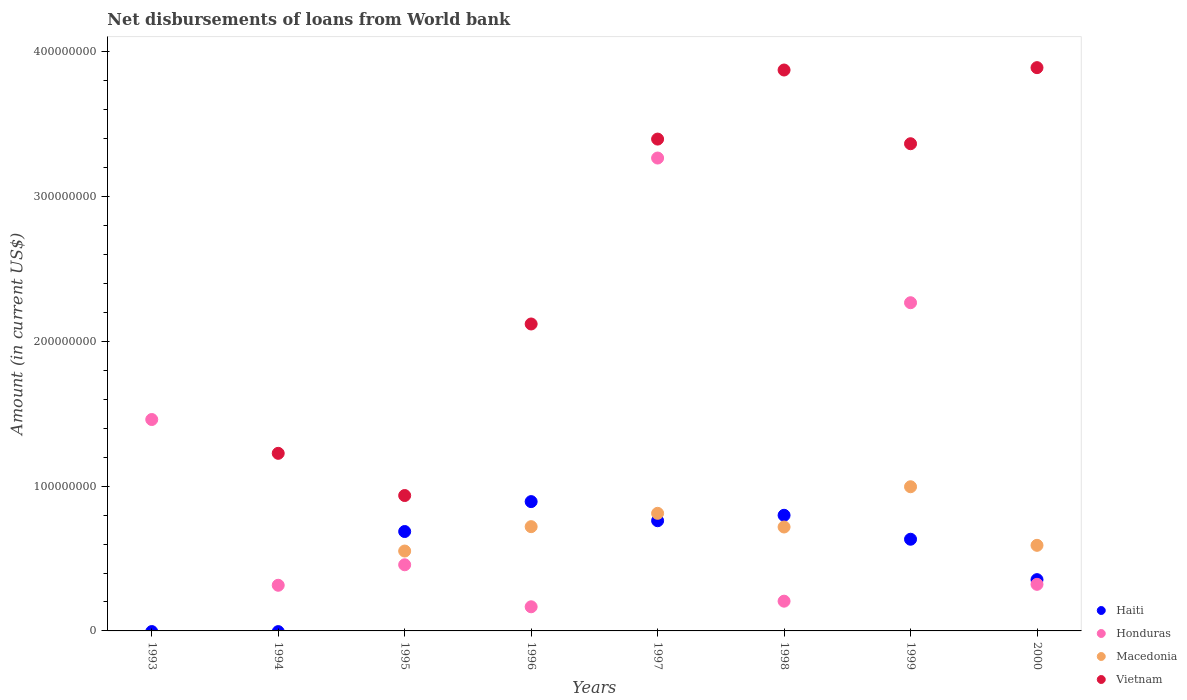Is the number of dotlines equal to the number of legend labels?
Your response must be concise. No. What is the amount of loan disbursed from World Bank in Haiti in 1999?
Offer a very short reply. 6.33e+07. Across all years, what is the maximum amount of loan disbursed from World Bank in Macedonia?
Offer a very short reply. 9.96e+07. What is the total amount of loan disbursed from World Bank in Vietnam in the graph?
Provide a succinct answer. 1.88e+09. What is the difference between the amount of loan disbursed from World Bank in Honduras in 1994 and that in 1998?
Give a very brief answer. 1.10e+07. What is the difference between the amount of loan disbursed from World Bank in Honduras in 1994 and the amount of loan disbursed from World Bank in Macedonia in 1997?
Provide a succinct answer. -4.97e+07. What is the average amount of loan disbursed from World Bank in Vietnam per year?
Ensure brevity in your answer.  2.35e+08. In the year 2000, what is the difference between the amount of loan disbursed from World Bank in Vietnam and amount of loan disbursed from World Bank in Macedonia?
Give a very brief answer. 3.30e+08. In how many years, is the amount of loan disbursed from World Bank in Haiti greater than 340000000 US$?
Ensure brevity in your answer.  0. What is the ratio of the amount of loan disbursed from World Bank in Honduras in 1995 to that in 1998?
Give a very brief answer. 2.22. Is the difference between the amount of loan disbursed from World Bank in Vietnam in 1995 and 1998 greater than the difference between the amount of loan disbursed from World Bank in Macedonia in 1995 and 1998?
Make the answer very short. No. What is the difference between the highest and the second highest amount of loan disbursed from World Bank in Haiti?
Provide a short and direct response. 9.45e+06. What is the difference between the highest and the lowest amount of loan disbursed from World Bank in Macedonia?
Make the answer very short. 9.96e+07. Does the amount of loan disbursed from World Bank in Vietnam monotonically increase over the years?
Make the answer very short. No. Is the amount of loan disbursed from World Bank in Haiti strictly greater than the amount of loan disbursed from World Bank in Honduras over the years?
Your answer should be very brief. No. How many dotlines are there?
Make the answer very short. 4. Are the values on the major ticks of Y-axis written in scientific E-notation?
Provide a short and direct response. No. Does the graph contain any zero values?
Your answer should be compact. Yes. Does the graph contain grids?
Make the answer very short. No. What is the title of the graph?
Provide a succinct answer. Net disbursements of loans from World bank. What is the label or title of the X-axis?
Provide a succinct answer. Years. What is the label or title of the Y-axis?
Provide a short and direct response. Amount (in current US$). What is the Amount (in current US$) of Haiti in 1993?
Keep it short and to the point. 0. What is the Amount (in current US$) of Honduras in 1993?
Make the answer very short. 1.46e+08. What is the Amount (in current US$) in Macedonia in 1993?
Ensure brevity in your answer.  0. What is the Amount (in current US$) in Vietnam in 1993?
Your answer should be very brief. 0. What is the Amount (in current US$) in Honduras in 1994?
Your answer should be compact. 3.15e+07. What is the Amount (in current US$) of Vietnam in 1994?
Your answer should be very brief. 1.23e+08. What is the Amount (in current US$) of Haiti in 1995?
Offer a very short reply. 6.87e+07. What is the Amount (in current US$) of Honduras in 1995?
Your answer should be compact. 4.57e+07. What is the Amount (in current US$) of Macedonia in 1995?
Offer a terse response. 5.52e+07. What is the Amount (in current US$) in Vietnam in 1995?
Your answer should be very brief. 9.35e+07. What is the Amount (in current US$) of Haiti in 1996?
Offer a very short reply. 8.93e+07. What is the Amount (in current US$) of Honduras in 1996?
Provide a succinct answer. 1.67e+07. What is the Amount (in current US$) of Macedonia in 1996?
Keep it short and to the point. 7.20e+07. What is the Amount (in current US$) in Vietnam in 1996?
Keep it short and to the point. 2.12e+08. What is the Amount (in current US$) in Haiti in 1997?
Give a very brief answer. 7.61e+07. What is the Amount (in current US$) in Honduras in 1997?
Offer a terse response. 3.27e+08. What is the Amount (in current US$) in Macedonia in 1997?
Your response must be concise. 8.12e+07. What is the Amount (in current US$) in Vietnam in 1997?
Provide a short and direct response. 3.40e+08. What is the Amount (in current US$) of Haiti in 1998?
Ensure brevity in your answer.  7.99e+07. What is the Amount (in current US$) in Honduras in 1998?
Your response must be concise. 2.05e+07. What is the Amount (in current US$) of Macedonia in 1998?
Offer a very short reply. 7.18e+07. What is the Amount (in current US$) of Vietnam in 1998?
Keep it short and to the point. 3.87e+08. What is the Amount (in current US$) in Haiti in 1999?
Provide a succinct answer. 6.33e+07. What is the Amount (in current US$) of Honduras in 1999?
Offer a very short reply. 2.27e+08. What is the Amount (in current US$) of Macedonia in 1999?
Your response must be concise. 9.96e+07. What is the Amount (in current US$) in Vietnam in 1999?
Offer a terse response. 3.36e+08. What is the Amount (in current US$) in Haiti in 2000?
Your response must be concise. 3.54e+07. What is the Amount (in current US$) of Honduras in 2000?
Your response must be concise. 3.22e+07. What is the Amount (in current US$) in Macedonia in 2000?
Offer a terse response. 5.91e+07. What is the Amount (in current US$) of Vietnam in 2000?
Your answer should be compact. 3.89e+08. Across all years, what is the maximum Amount (in current US$) of Haiti?
Provide a short and direct response. 8.93e+07. Across all years, what is the maximum Amount (in current US$) in Honduras?
Give a very brief answer. 3.27e+08. Across all years, what is the maximum Amount (in current US$) in Macedonia?
Offer a terse response. 9.96e+07. Across all years, what is the maximum Amount (in current US$) in Vietnam?
Your answer should be very brief. 3.89e+08. Across all years, what is the minimum Amount (in current US$) in Haiti?
Make the answer very short. 0. Across all years, what is the minimum Amount (in current US$) of Honduras?
Offer a very short reply. 1.67e+07. What is the total Amount (in current US$) in Haiti in the graph?
Your answer should be compact. 4.13e+08. What is the total Amount (in current US$) of Honduras in the graph?
Provide a succinct answer. 8.46e+08. What is the total Amount (in current US$) of Macedonia in the graph?
Keep it short and to the point. 4.39e+08. What is the total Amount (in current US$) in Vietnam in the graph?
Offer a terse response. 1.88e+09. What is the difference between the Amount (in current US$) of Honduras in 1993 and that in 1994?
Offer a very short reply. 1.14e+08. What is the difference between the Amount (in current US$) in Honduras in 1993 and that in 1995?
Your answer should be compact. 1.00e+08. What is the difference between the Amount (in current US$) of Honduras in 1993 and that in 1996?
Your response must be concise. 1.29e+08. What is the difference between the Amount (in current US$) of Honduras in 1993 and that in 1997?
Give a very brief answer. -1.81e+08. What is the difference between the Amount (in current US$) of Honduras in 1993 and that in 1998?
Provide a short and direct response. 1.25e+08. What is the difference between the Amount (in current US$) in Honduras in 1993 and that in 1999?
Make the answer very short. -8.07e+07. What is the difference between the Amount (in current US$) in Honduras in 1993 and that in 2000?
Keep it short and to the point. 1.14e+08. What is the difference between the Amount (in current US$) in Honduras in 1994 and that in 1995?
Ensure brevity in your answer.  -1.41e+07. What is the difference between the Amount (in current US$) of Vietnam in 1994 and that in 1995?
Your answer should be very brief. 2.91e+07. What is the difference between the Amount (in current US$) in Honduras in 1994 and that in 1996?
Your answer should be compact. 1.49e+07. What is the difference between the Amount (in current US$) in Vietnam in 1994 and that in 1996?
Make the answer very short. -8.93e+07. What is the difference between the Amount (in current US$) of Honduras in 1994 and that in 1997?
Provide a short and direct response. -2.95e+08. What is the difference between the Amount (in current US$) of Vietnam in 1994 and that in 1997?
Provide a short and direct response. -2.17e+08. What is the difference between the Amount (in current US$) in Honduras in 1994 and that in 1998?
Your answer should be compact. 1.10e+07. What is the difference between the Amount (in current US$) of Vietnam in 1994 and that in 1998?
Keep it short and to the point. -2.65e+08. What is the difference between the Amount (in current US$) of Honduras in 1994 and that in 1999?
Provide a succinct answer. -1.95e+08. What is the difference between the Amount (in current US$) of Vietnam in 1994 and that in 1999?
Ensure brevity in your answer.  -2.14e+08. What is the difference between the Amount (in current US$) of Honduras in 1994 and that in 2000?
Offer a very short reply. -6.47e+05. What is the difference between the Amount (in current US$) of Vietnam in 1994 and that in 2000?
Your answer should be very brief. -2.66e+08. What is the difference between the Amount (in current US$) of Haiti in 1995 and that in 1996?
Keep it short and to the point. -2.07e+07. What is the difference between the Amount (in current US$) of Honduras in 1995 and that in 1996?
Your answer should be very brief. 2.90e+07. What is the difference between the Amount (in current US$) in Macedonia in 1995 and that in 1996?
Provide a short and direct response. -1.68e+07. What is the difference between the Amount (in current US$) of Vietnam in 1995 and that in 1996?
Your response must be concise. -1.18e+08. What is the difference between the Amount (in current US$) of Haiti in 1995 and that in 1997?
Your response must be concise. -7.46e+06. What is the difference between the Amount (in current US$) in Honduras in 1995 and that in 1997?
Your response must be concise. -2.81e+08. What is the difference between the Amount (in current US$) in Macedonia in 1995 and that in 1997?
Keep it short and to the point. -2.60e+07. What is the difference between the Amount (in current US$) of Vietnam in 1995 and that in 1997?
Offer a terse response. -2.46e+08. What is the difference between the Amount (in current US$) in Haiti in 1995 and that in 1998?
Keep it short and to the point. -1.12e+07. What is the difference between the Amount (in current US$) of Honduras in 1995 and that in 1998?
Offer a very short reply. 2.51e+07. What is the difference between the Amount (in current US$) in Macedonia in 1995 and that in 1998?
Your response must be concise. -1.66e+07. What is the difference between the Amount (in current US$) in Vietnam in 1995 and that in 1998?
Provide a succinct answer. -2.94e+08. What is the difference between the Amount (in current US$) of Haiti in 1995 and that in 1999?
Ensure brevity in your answer.  5.33e+06. What is the difference between the Amount (in current US$) of Honduras in 1995 and that in 1999?
Offer a terse response. -1.81e+08. What is the difference between the Amount (in current US$) of Macedonia in 1995 and that in 1999?
Offer a very short reply. -4.44e+07. What is the difference between the Amount (in current US$) in Vietnam in 1995 and that in 1999?
Provide a short and direct response. -2.43e+08. What is the difference between the Amount (in current US$) of Haiti in 1995 and that in 2000?
Offer a very short reply. 3.32e+07. What is the difference between the Amount (in current US$) in Honduras in 1995 and that in 2000?
Ensure brevity in your answer.  1.35e+07. What is the difference between the Amount (in current US$) of Macedonia in 1995 and that in 2000?
Keep it short and to the point. -3.94e+06. What is the difference between the Amount (in current US$) of Vietnam in 1995 and that in 2000?
Offer a very short reply. -2.96e+08. What is the difference between the Amount (in current US$) of Haiti in 1996 and that in 1997?
Offer a terse response. 1.32e+07. What is the difference between the Amount (in current US$) of Honduras in 1996 and that in 1997?
Ensure brevity in your answer.  -3.10e+08. What is the difference between the Amount (in current US$) of Macedonia in 1996 and that in 1997?
Your response must be concise. -9.21e+06. What is the difference between the Amount (in current US$) in Vietnam in 1996 and that in 1997?
Give a very brief answer. -1.28e+08. What is the difference between the Amount (in current US$) in Haiti in 1996 and that in 1998?
Make the answer very short. 9.45e+06. What is the difference between the Amount (in current US$) in Honduras in 1996 and that in 1998?
Offer a very short reply. -3.87e+06. What is the difference between the Amount (in current US$) of Macedonia in 1996 and that in 1998?
Ensure brevity in your answer.  2.31e+05. What is the difference between the Amount (in current US$) in Vietnam in 1996 and that in 1998?
Your answer should be compact. -1.75e+08. What is the difference between the Amount (in current US$) in Haiti in 1996 and that in 1999?
Make the answer very short. 2.60e+07. What is the difference between the Amount (in current US$) in Honduras in 1996 and that in 1999?
Make the answer very short. -2.10e+08. What is the difference between the Amount (in current US$) of Macedonia in 1996 and that in 1999?
Offer a terse response. -2.76e+07. What is the difference between the Amount (in current US$) of Vietnam in 1996 and that in 1999?
Make the answer very short. -1.24e+08. What is the difference between the Amount (in current US$) in Haiti in 1996 and that in 2000?
Ensure brevity in your answer.  5.39e+07. What is the difference between the Amount (in current US$) in Honduras in 1996 and that in 2000?
Offer a very short reply. -1.55e+07. What is the difference between the Amount (in current US$) in Macedonia in 1996 and that in 2000?
Give a very brief answer. 1.29e+07. What is the difference between the Amount (in current US$) of Vietnam in 1996 and that in 2000?
Ensure brevity in your answer.  -1.77e+08. What is the difference between the Amount (in current US$) in Haiti in 1997 and that in 1998?
Offer a very short reply. -3.75e+06. What is the difference between the Amount (in current US$) of Honduras in 1997 and that in 1998?
Provide a short and direct response. 3.06e+08. What is the difference between the Amount (in current US$) in Macedonia in 1997 and that in 1998?
Give a very brief answer. 9.44e+06. What is the difference between the Amount (in current US$) of Vietnam in 1997 and that in 1998?
Give a very brief answer. -4.77e+07. What is the difference between the Amount (in current US$) of Haiti in 1997 and that in 1999?
Your answer should be compact. 1.28e+07. What is the difference between the Amount (in current US$) of Honduras in 1997 and that in 1999?
Offer a terse response. 9.99e+07. What is the difference between the Amount (in current US$) of Macedonia in 1997 and that in 1999?
Offer a terse response. -1.84e+07. What is the difference between the Amount (in current US$) in Vietnam in 1997 and that in 1999?
Offer a terse response. 3.21e+06. What is the difference between the Amount (in current US$) in Haiti in 1997 and that in 2000?
Provide a short and direct response. 4.07e+07. What is the difference between the Amount (in current US$) of Honduras in 1997 and that in 2000?
Give a very brief answer. 2.94e+08. What is the difference between the Amount (in current US$) in Macedonia in 1997 and that in 2000?
Your answer should be very brief. 2.21e+07. What is the difference between the Amount (in current US$) of Vietnam in 1997 and that in 2000?
Ensure brevity in your answer.  -4.93e+07. What is the difference between the Amount (in current US$) in Haiti in 1998 and that in 1999?
Your answer should be compact. 1.65e+07. What is the difference between the Amount (in current US$) in Honduras in 1998 and that in 1999?
Keep it short and to the point. -2.06e+08. What is the difference between the Amount (in current US$) of Macedonia in 1998 and that in 1999?
Your response must be concise. -2.78e+07. What is the difference between the Amount (in current US$) in Vietnam in 1998 and that in 1999?
Your answer should be compact. 5.09e+07. What is the difference between the Amount (in current US$) of Haiti in 1998 and that in 2000?
Make the answer very short. 4.44e+07. What is the difference between the Amount (in current US$) of Honduras in 1998 and that in 2000?
Give a very brief answer. -1.16e+07. What is the difference between the Amount (in current US$) of Macedonia in 1998 and that in 2000?
Give a very brief answer. 1.27e+07. What is the difference between the Amount (in current US$) in Vietnam in 1998 and that in 2000?
Keep it short and to the point. -1.64e+06. What is the difference between the Amount (in current US$) in Haiti in 1999 and that in 2000?
Your answer should be very brief. 2.79e+07. What is the difference between the Amount (in current US$) in Honduras in 1999 and that in 2000?
Provide a short and direct response. 1.94e+08. What is the difference between the Amount (in current US$) of Macedonia in 1999 and that in 2000?
Offer a very short reply. 4.05e+07. What is the difference between the Amount (in current US$) in Vietnam in 1999 and that in 2000?
Ensure brevity in your answer.  -5.26e+07. What is the difference between the Amount (in current US$) of Honduras in 1993 and the Amount (in current US$) of Vietnam in 1994?
Make the answer very short. 2.34e+07. What is the difference between the Amount (in current US$) of Honduras in 1993 and the Amount (in current US$) of Macedonia in 1995?
Make the answer very short. 9.08e+07. What is the difference between the Amount (in current US$) in Honduras in 1993 and the Amount (in current US$) in Vietnam in 1995?
Provide a succinct answer. 5.25e+07. What is the difference between the Amount (in current US$) of Honduras in 1993 and the Amount (in current US$) of Macedonia in 1996?
Keep it short and to the point. 7.40e+07. What is the difference between the Amount (in current US$) of Honduras in 1993 and the Amount (in current US$) of Vietnam in 1996?
Give a very brief answer. -6.60e+07. What is the difference between the Amount (in current US$) of Honduras in 1993 and the Amount (in current US$) of Macedonia in 1997?
Provide a succinct answer. 6.48e+07. What is the difference between the Amount (in current US$) in Honduras in 1993 and the Amount (in current US$) in Vietnam in 1997?
Offer a terse response. -1.94e+08. What is the difference between the Amount (in current US$) in Honduras in 1993 and the Amount (in current US$) in Macedonia in 1998?
Keep it short and to the point. 7.42e+07. What is the difference between the Amount (in current US$) of Honduras in 1993 and the Amount (in current US$) of Vietnam in 1998?
Offer a very short reply. -2.41e+08. What is the difference between the Amount (in current US$) in Honduras in 1993 and the Amount (in current US$) in Macedonia in 1999?
Make the answer very short. 4.64e+07. What is the difference between the Amount (in current US$) in Honduras in 1993 and the Amount (in current US$) in Vietnam in 1999?
Your response must be concise. -1.90e+08. What is the difference between the Amount (in current US$) of Honduras in 1993 and the Amount (in current US$) of Macedonia in 2000?
Offer a very short reply. 8.69e+07. What is the difference between the Amount (in current US$) in Honduras in 1993 and the Amount (in current US$) in Vietnam in 2000?
Provide a short and direct response. -2.43e+08. What is the difference between the Amount (in current US$) in Honduras in 1994 and the Amount (in current US$) in Macedonia in 1995?
Offer a terse response. -2.36e+07. What is the difference between the Amount (in current US$) of Honduras in 1994 and the Amount (in current US$) of Vietnam in 1995?
Ensure brevity in your answer.  -6.20e+07. What is the difference between the Amount (in current US$) of Honduras in 1994 and the Amount (in current US$) of Macedonia in 1996?
Make the answer very short. -4.05e+07. What is the difference between the Amount (in current US$) of Honduras in 1994 and the Amount (in current US$) of Vietnam in 1996?
Provide a succinct answer. -1.80e+08. What is the difference between the Amount (in current US$) in Honduras in 1994 and the Amount (in current US$) in Macedonia in 1997?
Keep it short and to the point. -4.97e+07. What is the difference between the Amount (in current US$) of Honduras in 1994 and the Amount (in current US$) of Vietnam in 1997?
Ensure brevity in your answer.  -3.08e+08. What is the difference between the Amount (in current US$) of Honduras in 1994 and the Amount (in current US$) of Macedonia in 1998?
Your response must be concise. -4.02e+07. What is the difference between the Amount (in current US$) in Honduras in 1994 and the Amount (in current US$) in Vietnam in 1998?
Give a very brief answer. -3.56e+08. What is the difference between the Amount (in current US$) of Honduras in 1994 and the Amount (in current US$) of Macedonia in 1999?
Give a very brief answer. -6.80e+07. What is the difference between the Amount (in current US$) of Honduras in 1994 and the Amount (in current US$) of Vietnam in 1999?
Your answer should be compact. -3.05e+08. What is the difference between the Amount (in current US$) in Honduras in 1994 and the Amount (in current US$) in Macedonia in 2000?
Offer a very short reply. -2.76e+07. What is the difference between the Amount (in current US$) in Honduras in 1994 and the Amount (in current US$) in Vietnam in 2000?
Ensure brevity in your answer.  -3.58e+08. What is the difference between the Amount (in current US$) in Haiti in 1995 and the Amount (in current US$) in Honduras in 1996?
Your answer should be very brief. 5.20e+07. What is the difference between the Amount (in current US$) of Haiti in 1995 and the Amount (in current US$) of Macedonia in 1996?
Ensure brevity in your answer.  -3.36e+06. What is the difference between the Amount (in current US$) in Haiti in 1995 and the Amount (in current US$) in Vietnam in 1996?
Provide a short and direct response. -1.43e+08. What is the difference between the Amount (in current US$) in Honduras in 1995 and the Amount (in current US$) in Macedonia in 1996?
Ensure brevity in your answer.  -2.63e+07. What is the difference between the Amount (in current US$) in Honduras in 1995 and the Amount (in current US$) in Vietnam in 1996?
Your answer should be very brief. -1.66e+08. What is the difference between the Amount (in current US$) in Macedonia in 1995 and the Amount (in current US$) in Vietnam in 1996?
Offer a terse response. -1.57e+08. What is the difference between the Amount (in current US$) of Haiti in 1995 and the Amount (in current US$) of Honduras in 1997?
Your answer should be compact. -2.58e+08. What is the difference between the Amount (in current US$) of Haiti in 1995 and the Amount (in current US$) of Macedonia in 1997?
Your response must be concise. -1.26e+07. What is the difference between the Amount (in current US$) of Haiti in 1995 and the Amount (in current US$) of Vietnam in 1997?
Your answer should be very brief. -2.71e+08. What is the difference between the Amount (in current US$) of Honduras in 1995 and the Amount (in current US$) of Macedonia in 1997?
Ensure brevity in your answer.  -3.55e+07. What is the difference between the Amount (in current US$) in Honduras in 1995 and the Amount (in current US$) in Vietnam in 1997?
Your response must be concise. -2.94e+08. What is the difference between the Amount (in current US$) of Macedonia in 1995 and the Amount (in current US$) of Vietnam in 1997?
Keep it short and to the point. -2.85e+08. What is the difference between the Amount (in current US$) in Haiti in 1995 and the Amount (in current US$) in Honduras in 1998?
Give a very brief answer. 4.81e+07. What is the difference between the Amount (in current US$) of Haiti in 1995 and the Amount (in current US$) of Macedonia in 1998?
Offer a terse response. -3.12e+06. What is the difference between the Amount (in current US$) of Haiti in 1995 and the Amount (in current US$) of Vietnam in 1998?
Give a very brief answer. -3.19e+08. What is the difference between the Amount (in current US$) of Honduras in 1995 and the Amount (in current US$) of Macedonia in 1998?
Make the answer very short. -2.61e+07. What is the difference between the Amount (in current US$) in Honduras in 1995 and the Amount (in current US$) in Vietnam in 1998?
Offer a very short reply. -3.42e+08. What is the difference between the Amount (in current US$) of Macedonia in 1995 and the Amount (in current US$) of Vietnam in 1998?
Provide a short and direct response. -3.32e+08. What is the difference between the Amount (in current US$) in Haiti in 1995 and the Amount (in current US$) in Honduras in 1999?
Provide a short and direct response. -1.58e+08. What is the difference between the Amount (in current US$) of Haiti in 1995 and the Amount (in current US$) of Macedonia in 1999?
Offer a very short reply. -3.09e+07. What is the difference between the Amount (in current US$) of Haiti in 1995 and the Amount (in current US$) of Vietnam in 1999?
Ensure brevity in your answer.  -2.68e+08. What is the difference between the Amount (in current US$) in Honduras in 1995 and the Amount (in current US$) in Macedonia in 1999?
Your answer should be very brief. -5.39e+07. What is the difference between the Amount (in current US$) in Honduras in 1995 and the Amount (in current US$) in Vietnam in 1999?
Your answer should be very brief. -2.91e+08. What is the difference between the Amount (in current US$) of Macedonia in 1995 and the Amount (in current US$) of Vietnam in 1999?
Keep it short and to the point. -2.81e+08. What is the difference between the Amount (in current US$) of Haiti in 1995 and the Amount (in current US$) of Honduras in 2000?
Keep it short and to the point. 3.65e+07. What is the difference between the Amount (in current US$) of Haiti in 1995 and the Amount (in current US$) of Macedonia in 2000?
Your answer should be compact. 9.54e+06. What is the difference between the Amount (in current US$) of Haiti in 1995 and the Amount (in current US$) of Vietnam in 2000?
Your answer should be very brief. -3.20e+08. What is the difference between the Amount (in current US$) in Honduras in 1995 and the Amount (in current US$) in Macedonia in 2000?
Ensure brevity in your answer.  -1.34e+07. What is the difference between the Amount (in current US$) of Honduras in 1995 and the Amount (in current US$) of Vietnam in 2000?
Provide a succinct answer. -3.43e+08. What is the difference between the Amount (in current US$) of Macedonia in 1995 and the Amount (in current US$) of Vietnam in 2000?
Your answer should be very brief. -3.34e+08. What is the difference between the Amount (in current US$) of Haiti in 1996 and the Amount (in current US$) of Honduras in 1997?
Your answer should be compact. -2.37e+08. What is the difference between the Amount (in current US$) in Haiti in 1996 and the Amount (in current US$) in Macedonia in 1997?
Keep it short and to the point. 8.09e+06. What is the difference between the Amount (in current US$) in Haiti in 1996 and the Amount (in current US$) in Vietnam in 1997?
Your response must be concise. -2.50e+08. What is the difference between the Amount (in current US$) in Honduras in 1996 and the Amount (in current US$) in Macedonia in 1997?
Give a very brief answer. -6.46e+07. What is the difference between the Amount (in current US$) in Honduras in 1996 and the Amount (in current US$) in Vietnam in 1997?
Keep it short and to the point. -3.23e+08. What is the difference between the Amount (in current US$) in Macedonia in 1996 and the Amount (in current US$) in Vietnam in 1997?
Offer a very short reply. -2.68e+08. What is the difference between the Amount (in current US$) in Haiti in 1996 and the Amount (in current US$) in Honduras in 1998?
Your response must be concise. 6.88e+07. What is the difference between the Amount (in current US$) of Haiti in 1996 and the Amount (in current US$) of Macedonia in 1998?
Make the answer very short. 1.75e+07. What is the difference between the Amount (in current US$) of Haiti in 1996 and the Amount (in current US$) of Vietnam in 1998?
Provide a short and direct response. -2.98e+08. What is the difference between the Amount (in current US$) of Honduras in 1996 and the Amount (in current US$) of Macedonia in 1998?
Your answer should be compact. -5.51e+07. What is the difference between the Amount (in current US$) of Honduras in 1996 and the Amount (in current US$) of Vietnam in 1998?
Offer a terse response. -3.71e+08. What is the difference between the Amount (in current US$) in Macedonia in 1996 and the Amount (in current US$) in Vietnam in 1998?
Ensure brevity in your answer.  -3.15e+08. What is the difference between the Amount (in current US$) in Haiti in 1996 and the Amount (in current US$) in Honduras in 1999?
Offer a terse response. -1.37e+08. What is the difference between the Amount (in current US$) in Haiti in 1996 and the Amount (in current US$) in Macedonia in 1999?
Give a very brief answer. -1.03e+07. What is the difference between the Amount (in current US$) in Haiti in 1996 and the Amount (in current US$) in Vietnam in 1999?
Your answer should be compact. -2.47e+08. What is the difference between the Amount (in current US$) of Honduras in 1996 and the Amount (in current US$) of Macedonia in 1999?
Give a very brief answer. -8.29e+07. What is the difference between the Amount (in current US$) of Honduras in 1996 and the Amount (in current US$) of Vietnam in 1999?
Offer a terse response. -3.20e+08. What is the difference between the Amount (in current US$) of Macedonia in 1996 and the Amount (in current US$) of Vietnam in 1999?
Make the answer very short. -2.64e+08. What is the difference between the Amount (in current US$) of Haiti in 1996 and the Amount (in current US$) of Honduras in 2000?
Give a very brief answer. 5.71e+07. What is the difference between the Amount (in current US$) of Haiti in 1996 and the Amount (in current US$) of Macedonia in 2000?
Your response must be concise. 3.02e+07. What is the difference between the Amount (in current US$) of Haiti in 1996 and the Amount (in current US$) of Vietnam in 2000?
Provide a succinct answer. -3.00e+08. What is the difference between the Amount (in current US$) in Honduras in 1996 and the Amount (in current US$) in Macedonia in 2000?
Provide a short and direct response. -4.24e+07. What is the difference between the Amount (in current US$) of Honduras in 1996 and the Amount (in current US$) of Vietnam in 2000?
Your answer should be compact. -3.72e+08. What is the difference between the Amount (in current US$) of Macedonia in 1996 and the Amount (in current US$) of Vietnam in 2000?
Offer a terse response. -3.17e+08. What is the difference between the Amount (in current US$) in Haiti in 1997 and the Amount (in current US$) in Honduras in 1998?
Ensure brevity in your answer.  5.56e+07. What is the difference between the Amount (in current US$) in Haiti in 1997 and the Amount (in current US$) in Macedonia in 1998?
Offer a very short reply. 4.33e+06. What is the difference between the Amount (in current US$) of Haiti in 1997 and the Amount (in current US$) of Vietnam in 1998?
Make the answer very short. -3.11e+08. What is the difference between the Amount (in current US$) of Honduras in 1997 and the Amount (in current US$) of Macedonia in 1998?
Keep it short and to the point. 2.55e+08. What is the difference between the Amount (in current US$) in Honduras in 1997 and the Amount (in current US$) in Vietnam in 1998?
Make the answer very short. -6.08e+07. What is the difference between the Amount (in current US$) in Macedonia in 1997 and the Amount (in current US$) in Vietnam in 1998?
Provide a short and direct response. -3.06e+08. What is the difference between the Amount (in current US$) in Haiti in 1997 and the Amount (in current US$) in Honduras in 1999?
Provide a short and direct response. -1.51e+08. What is the difference between the Amount (in current US$) in Haiti in 1997 and the Amount (in current US$) in Macedonia in 1999?
Your answer should be very brief. -2.35e+07. What is the difference between the Amount (in current US$) of Haiti in 1997 and the Amount (in current US$) of Vietnam in 1999?
Your answer should be very brief. -2.60e+08. What is the difference between the Amount (in current US$) of Honduras in 1997 and the Amount (in current US$) of Macedonia in 1999?
Give a very brief answer. 2.27e+08. What is the difference between the Amount (in current US$) in Honduras in 1997 and the Amount (in current US$) in Vietnam in 1999?
Offer a terse response. -9.88e+06. What is the difference between the Amount (in current US$) of Macedonia in 1997 and the Amount (in current US$) of Vietnam in 1999?
Ensure brevity in your answer.  -2.55e+08. What is the difference between the Amount (in current US$) in Haiti in 1997 and the Amount (in current US$) in Honduras in 2000?
Provide a short and direct response. 4.39e+07. What is the difference between the Amount (in current US$) in Haiti in 1997 and the Amount (in current US$) in Macedonia in 2000?
Make the answer very short. 1.70e+07. What is the difference between the Amount (in current US$) of Haiti in 1997 and the Amount (in current US$) of Vietnam in 2000?
Make the answer very short. -3.13e+08. What is the difference between the Amount (in current US$) of Honduras in 1997 and the Amount (in current US$) of Macedonia in 2000?
Your answer should be compact. 2.67e+08. What is the difference between the Amount (in current US$) of Honduras in 1997 and the Amount (in current US$) of Vietnam in 2000?
Offer a terse response. -6.24e+07. What is the difference between the Amount (in current US$) of Macedonia in 1997 and the Amount (in current US$) of Vietnam in 2000?
Make the answer very short. -3.08e+08. What is the difference between the Amount (in current US$) of Haiti in 1998 and the Amount (in current US$) of Honduras in 1999?
Give a very brief answer. -1.47e+08. What is the difference between the Amount (in current US$) in Haiti in 1998 and the Amount (in current US$) in Macedonia in 1999?
Ensure brevity in your answer.  -1.97e+07. What is the difference between the Amount (in current US$) in Haiti in 1998 and the Amount (in current US$) in Vietnam in 1999?
Your answer should be compact. -2.57e+08. What is the difference between the Amount (in current US$) of Honduras in 1998 and the Amount (in current US$) of Macedonia in 1999?
Ensure brevity in your answer.  -7.90e+07. What is the difference between the Amount (in current US$) of Honduras in 1998 and the Amount (in current US$) of Vietnam in 1999?
Your answer should be very brief. -3.16e+08. What is the difference between the Amount (in current US$) of Macedonia in 1998 and the Amount (in current US$) of Vietnam in 1999?
Offer a terse response. -2.65e+08. What is the difference between the Amount (in current US$) of Haiti in 1998 and the Amount (in current US$) of Honduras in 2000?
Offer a very short reply. 4.77e+07. What is the difference between the Amount (in current US$) of Haiti in 1998 and the Amount (in current US$) of Macedonia in 2000?
Offer a very short reply. 2.07e+07. What is the difference between the Amount (in current US$) in Haiti in 1998 and the Amount (in current US$) in Vietnam in 2000?
Your response must be concise. -3.09e+08. What is the difference between the Amount (in current US$) in Honduras in 1998 and the Amount (in current US$) in Macedonia in 2000?
Offer a very short reply. -3.86e+07. What is the difference between the Amount (in current US$) of Honduras in 1998 and the Amount (in current US$) of Vietnam in 2000?
Your response must be concise. -3.68e+08. What is the difference between the Amount (in current US$) in Macedonia in 1998 and the Amount (in current US$) in Vietnam in 2000?
Offer a terse response. -3.17e+08. What is the difference between the Amount (in current US$) of Haiti in 1999 and the Amount (in current US$) of Honduras in 2000?
Provide a succinct answer. 3.11e+07. What is the difference between the Amount (in current US$) in Haiti in 1999 and the Amount (in current US$) in Macedonia in 2000?
Provide a short and direct response. 4.21e+06. What is the difference between the Amount (in current US$) of Haiti in 1999 and the Amount (in current US$) of Vietnam in 2000?
Offer a terse response. -3.26e+08. What is the difference between the Amount (in current US$) in Honduras in 1999 and the Amount (in current US$) in Macedonia in 2000?
Your answer should be compact. 1.68e+08. What is the difference between the Amount (in current US$) of Honduras in 1999 and the Amount (in current US$) of Vietnam in 2000?
Offer a terse response. -1.62e+08. What is the difference between the Amount (in current US$) of Macedonia in 1999 and the Amount (in current US$) of Vietnam in 2000?
Offer a very short reply. -2.89e+08. What is the average Amount (in current US$) of Haiti per year?
Ensure brevity in your answer.  5.16e+07. What is the average Amount (in current US$) of Honduras per year?
Offer a very short reply. 1.06e+08. What is the average Amount (in current US$) in Macedonia per year?
Your answer should be very brief. 5.49e+07. What is the average Amount (in current US$) in Vietnam per year?
Provide a short and direct response. 2.35e+08. In the year 1994, what is the difference between the Amount (in current US$) in Honduras and Amount (in current US$) in Vietnam?
Keep it short and to the point. -9.11e+07. In the year 1995, what is the difference between the Amount (in current US$) in Haiti and Amount (in current US$) in Honduras?
Make the answer very short. 2.30e+07. In the year 1995, what is the difference between the Amount (in current US$) in Haiti and Amount (in current US$) in Macedonia?
Provide a succinct answer. 1.35e+07. In the year 1995, what is the difference between the Amount (in current US$) in Haiti and Amount (in current US$) in Vietnam?
Keep it short and to the point. -2.49e+07. In the year 1995, what is the difference between the Amount (in current US$) in Honduras and Amount (in current US$) in Macedonia?
Your response must be concise. -9.49e+06. In the year 1995, what is the difference between the Amount (in current US$) of Honduras and Amount (in current US$) of Vietnam?
Your answer should be compact. -4.78e+07. In the year 1995, what is the difference between the Amount (in current US$) of Macedonia and Amount (in current US$) of Vietnam?
Keep it short and to the point. -3.83e+07. In the year 1996, what is the difference between the Amount (in current US$) of Haiti and Amount (in current US$) of Honduras?
Your answer should be very brief. 7.26e+07. In the year 1996, what is the difference between the Amount (in current US$) in Haiti and Amount (in current US$) in Macedonia?
Provide a short and direct response. 1.73e+07. In the year 1996, what is the difference between the Amount (in current US$) of Haiti and Amount (in current US$) of Vietnam?
Offer a very short reply. -1.23e+08. In the year 1996, what is the difference between the Amount (in current US$) in Honduras and Amount (in current US$) in Macedonia?
Keep it short and to the point. -5.53e+07. In the year 1996, what is the difference between the Amount (in current US$) in Honduras and Amount (in current US$) in Vietnam?
Make the answer very short. -1.95e+08. In the year 1996, what is the difference between the Amount (in current US$) of Macedonia and Amount (in current US$) of Vietnam?
Offer a very short reply. -1.40e+08. In the year 1997, what is the difference between the Amount (in current US$) of Haiti and Amount (in current US$) of Honduras?
Your response must be concise. -2.50e+08. In the year 1997, what is the difference between the Amount (in current US$) of Haiti and Amount (in current US$) of Macedonia?
Offer a terse response. -5.11e+06. In the year 1997, what is the difference between the Amount (in current US$) in Haiti and Amount (in current US$) in Vietnam?
Give a very brief answer. -2.64e+08. In the year 1997, what is the difference between the Amount (in current US$) of Honduras and Amount (in current US$) of Macedonia?
Your answer should be compact. 2.45e+08. In the year 1997, what is the difference between the Amount (in current US$) in Honduras and Amount (in current US$) in Vietnam?
Offer a terse response. -1.31e+07. In the year 1997, what is the difference between the Amount (in current US$) in Macedonia and Amount (in current US$) in Vietnam?
Give a very brief answer. -2.58e+08. In the year 1998, what is the difference between the Amount (in current US$) in Haiti and Amount (in current US$) in Honduras?
Offer a terse response. 5.93e+07. In the year 1998, what is the difference between the Amount (in current US$) of Haiti and Amount (in current US$) of Macedonia?
Provide a short and direct response. 8.08e+06. In the year 1998, what is the difference between the Amount (in current US$) in Haiti and Amount (in current US$) in Vietnam?
Provide a succinct answer. -3.08e+08. In the year 1998, what is the difference between the Amount (in current US$) of Honduras and Amount (in current US$) of Macedonia?
Your answer should be compact. -5.12e+07. In the year 1998, what is the difference between the Amount (in current US$) of Honduras and Amount (in current US$) of Vietnam?
Ensure brevity in your answer.  -3.67e+08. In the year 1998, what is the difference between the Amount (in current US$) in Macedonia and Amount (in current US$) in Vietnam?
Your answer should be compact. -3.16e+08. In the year 1999, what is the difference between the Amount (in current US$) of Haiti and Amount (in current US$) of Honduras?
Offer a terse response. -1.63e+08. In the year 1999, what is the difference between the Amount (in current US$) of Haiti and Amount (in current US$) of Macedonia?
Provide a succinct answer. -3.62e+07. In the year 1999, what is the difference between the Amount (in current US$) in Haiti and Amount (in current US$) in Vietnam?
Keep it short and to the point. -2.73e+08. In the year 1999, what is the difference between the Amount (in current US$) in Honduras and Amount (in current US$) in Macedonia?
Make the answer very short. 1.27e+08. In the year 1999, what is the difference between the Amount (in current US$) in Honduras and Amount (in current US$) in Vietnam?
Offer a very short reply. -1.10e+08. In the year 1999, what is the difference between the Amount (in current US$) of Macedonia and Amount (in current US$) of Vietnam?
Provide a short and direct response. -2.37e+08. In the year 2000, what is the difference between the Amount (in current US$) of Haiti and Amount (in current US$) of Honduras?
Your answer should be compact. 3.23e+06. In the year 2000, what is the difference between the Amount (in current US$) in Haiti and Amount (in current US$) in Macedonia?
Offer a very short reply. -2.37e+07. In the year 2000, what is the difference between the Amount (in current US$) in Haiti and Amount (in current US$) in Vietnam?
Your answer should be compact. -3.54e+08. In the year 2000, what is the difference between the Amount (in current US$) in Honduras and Amount (in current US$) in Macedonia?
Offer a terse response. -2.69e+07. In the year 2000, what is the difference between the Amount (in current US$) of Honduras and Amount (in current US$) of Vietnam?
Make the answer very short. -3.57e+08. In the year 2000, what is the difference between the Amount (in current US$) of Macedonia and Amount (in current US$) of Vietnam?
Your response must be concise. -3.30e+08. What is the ratio of the Amount (in current US$) of Honduras in 1993 to that in 1994?
Your response must be concise. 4.63. What is the ratio of the Amount (in current US$) in Honduras in 1993 to that in 1995?
Offer a terse response. 3.2. What is the ratio of the Amount (in current US$) in Honduras in 1993 to that in 1996?
Your answer should be compact. 8.76. What is the ratio of the Amount (in current US$) of Honduras in 1993 to that in 1997?
Ensure brevity in your answer.  0.45. What is the ratio of the Amount (in current US$) of Honduras in 1993 to that in 1998?
Ensure brevity in your answer.  7.11. What is the ratio of the Amount (in current US$) in Honduras in 1993 to that in 1999?
Ensure brevity in your answer.  0.64. What is the ratio of the Amount (in current US$) of Honduras in 1993 to that in 2000?
Give a very brief answer. 4.54. What is the ratio of the Amount (in current US$) in Honduras in 1994 to that in 1995?
Make the answer very short. 0.69. What is the ratio of the Amount (in current US$) of Vietnam in 1994 to that in 1995?
Provide a short and direct response. 1.31. What is the ratio of the Amount (in current US$) in Honduras in 1994 to that in 1996?
Your response must be concise. 1.89. What is the ratio of the Amount (in current US$) in Vietnam in 1994 to that in 1996?
Offer a terse response. 0.58. What is the ratio of the Amount (in current US$) of Honduras in 1994 to that in 1997?
Ensure brevity in your answer.  0.1. What is the ratio of the Amount (in current US$) of Vietnam in 1994 to that in 1997?
Your response must be concise. 0.36. What is the ratio of the Amount (in current US$) of Honduras in 1994 to that in 1998?
Make the answer very short. 1.53. What is the ratio of the Amount (in current US$) in Vietnam in 1994 to that in 1998?
Provide a short and direct response. 0.32. What is the ratio of the Amount (in current US$) in Honduras in 1994 to that in 1999?
Ensure brevity in your answer.  0.14. What is the ratio of the Amount (in current US$) in Vietnam in 1994 to that in 1999?
Provide a short and direct response. 0.36. What is the ratio of the Amount (in current US$) of Honduras in 1994 to that in 2000?
Your answer should be very brief. 0.98. What is the ratio of the Amount (in current US$) in Vietnam in 1994 to that in 2000?
Provide a succinct answer. 0.32. What is the ratio of the Amount (in current US$) of Haiti in 1995 to that in 1996?
Provide a short and direct response. 0.77. What is the ratio of the Amount (in current US$) in Honduras in 1995 to that in 1996?
Keep it short and to the point. 2.74. What is the ratio of the Amount (in current US$) of Macedonia in 1995 to that in 1996?
Offer a very short reply. 0.77. What is the ratio of the Amount (in current US$) of Vietnam in 1995 to that in 1996?
Give a very brief answer. 0.44. What is the ratio of the Amount (in current US$) of Haiti in 1995 to that in 1997?
Keep it short and to the point. 0.9. What is the ratio of the Amount (in current US$) of Honduras in 1995 to that in 1997?
Give a very brief answer. 0.14. What is the ratio of the Amount (in current US$) of Macedonia in 1995 to that in 1997?
Offer a very short reply. 0.68. What is the ratio of the Amount (in current US$) of Vietnam in 1995 to that in 1997?
Your answer should be compact. 0.28. What is the ratio of the Amount (in current US$) of Haiti in 1995 to that in 1998?
Ensure brevity in your answer.  0.86. What is the ratio of the Amount (in current US$) of Honduras in 1995 to that in 1998?
Your answer should be very brief. 2.22. What is the ratio of the Amount (in current US$) of Macedonia in 1995 to that in 1998?
Your answer should be compact. 0.77. What is the ratio of the Amount (in current US$) in Vietnam in 1995 to that in 1998?
Keep it short and to the point. 0.24. What is the ratio of the Amount (in current US$) of Haiti in 1995 to that in 1999?
Keep it short and to the point. 1.08. What is the ratio of the Amount (in current US$) in Honduras in 1995 to that in 1999?
Provide a succinct answer. 0.2. What is the ratio of the Amount (in current US$) of Macedonia in 1995 to that in 1999?
Make the answer very short. 0.55. What is the ratio of the Amount (in current US$) of Vietnam in 1995 to that in 1999?
Your answer should be compact. 0.28. What is the ratio of the Amount (in current US$) of Haiti in 1995 to that in 2000?
Provide a short and direct response. 1.94. What is the ratio of the Amount (in current US$) of Honduras in 1995 to that in 2000?
Provide a succinct answer. 1.42. What is the ratio of the Amount (in current US$) of Vietnam in 1995 to that in 2000?
Make the answer very short. 0.24. What is the ratio of the Amount (in current US$) of Haiti in 1996 to that in 1997?
Offer a terse response. 1.17. What is the ratio of the Amount (in current US$) of Honduras in 1996 to that in 1997?
Offer a very short reply. 0.05. What is the ratio of the Amount (in current US$) in Macedonia in 1996 to that in 1997?
Make the answer very short. 0.89. What is the ratio of the Amount (in current US$) in Vietnam in 1996 to that in 1997?
Ensure brevity in your answer.  0.62. What is the ratio of the Amount (in current US$) in Haiti in 1996 to that in 1998?
Give a very brief answer. 1.12. What is the ratio of the Amount (in current US$) of Honduras in 1996 to that in 1998?
Offer a terse response. 0.81. What is the ratio of the Amount (in current US$) of Vietnam in 1996 to that in 1998?
Offer a very short reply. 0.55. What is the ratio of the Amount (in current US$) in Haiti in 1996 to that in 1999?
Ensure brevity in your answer.  1.41. What is the ratio of the Amount (in current US$) of Honduras in 1996 to that in 1999?
Offer a terse response. 0.07. What is the ratio of the Amount (in current US$) of Macedonia in 1996 to that in 1999?
Offer a terse response. 0.72. What is the ratio of the Amount (in current US$) of Vietnam in 1996 to that in 1999?
Provide a short and direct response. 0.63. What is the ratio of the Amount (in current US$) in Haiti in 1996 to that in 2000?
Your answer should be compact. 2.52. What is the ratio of the Amount (in current US$) in Honduras in 1996 to that in 2000?
Keep it short and to the point. 0.52. What is the ratio of the Amount (in current US$) in Macedonia in 1996 to that in 2000?
Your answer should be very brief. 1.22. What is the ratio of the Amount (in current US$) in Vietnam in 1996 to that in 2000?
Offer a very short reply. 0.54. What is the ratio of the Amount (in current US$) in Haiti in 1997 to that in 1998?
Your answer should be very brief. 0.95. What is the ratio of the Amount (in current US$) of Honduras in 1997 to that in 1998?
Your response must be concise. 15.9. What is the ratio of the Amount (in current US$) of Macedonia in 1997 to that in 1998?
Make the answer very short. 1.13. What is the ratio of the Amount (in current US$) in Vietnam in 1997 to that in 1998?
Make the answer very short. 0.88. What is the ratio of the Amount (in current US$) in Haiti in 1997 to that in 1999?
Your answer should be very brief. 1.2. What is the ratio of the Amount (in current US$) in Honduras in 1997 to that in 1999?
Provide a short and direct response. 1.44. What is the ratio of the Amount (in current US$) of Macedonia in 1997 to that in 1999?
Make the answer very short. 0.82. What is the ratio of the Amount (in current US$) of Vietnam in 1997 to that in 1999?
Your response must be concise. 1.01. What is the ratio of the Amount (in current US$) of Haiti in 1997 to that in 2000?
Your answer should be compact. 2.15. What is the ratio of the Amount (in current US$) in Honduras in 1997 to that in 2000?
Your answer should be compact. 10.15. What is the ratio of the Amount (in current US$) of Macedonia in 1997 to that in 2000?
Offer a very short reply. 1.37. What is the ratio of the Amount (in current US$) in Vietnam in 1997 to that in 2000?
Offer a terse response. 0.87. What is the ratio of the Amount (in current US$) of Haiti in 1998 to that in 1999?
Provide a succinct answer. 1.26. What is the ratio of the Amount (in current US$) in Honduras in 1998 to that in 1999?
Offer a very short reply. 0.09. What is the ratio of the Amount (in current US$) of Macedonia in 1998 to that in 1999?
Ensure brevity in your answer.  0.72. What is the ratio of the Amount (in current US$) of Vietnam in 1998 to that in 1999?
Make the answer very short. 1.15. What is the ratio of the Amount (in current US$) in Haiti in 1998 to that in 2000?
Your answer should be very brief. 2.26. What is the ratio of the Amount (in current US$) in Honduras in 1998 to that in 2000?
Make the answer very short. 0.64. What is the ratio of the Amount (in current US$) in Macedonia in 1998 to that in 2000?
Your answer should be very brief. 1.21. What is the ratio of the Amount (in current US$) of Vietnam in 1998 to that in 2000?
Give a very brief answer. 1. What is the ratio of the Amount (in current US$) in Haiti in 1999 to that in 2000?
Keep it short and to the point. 1.79. What is the ratio of the Amount (in current US$) in Honduras in 1999 to that in 2000?
Your answer should be compact. 7.04. What is the ratio of the Amount (in current US$) of Macedonia in 1999 to that in 2000?
Keep it short and to the point. 1.68. What is the ratio of the Amount (in current US$) in Vietnam in 1999 to that in 2000?
Keep it short and to the point. 0.86. What is the difference between the highest and the second highest Amount (in current US$) of Haiti?
Ensure brevity in your answer.  9.45e+06. What is the difference between the highest and the second highest Amount (in current US$) of Honduras?
Your answer should be compact. 9.99e+07. What is the difference between the highest and the second highest Amount (in current US$) in Macedonia?
Offer a very short reply. 1.84e+07. What is the difference between the highest and the second highest Amount (in current US$) of Vietnam?
Offer a terse response. 1.64e+06. What is the difference between the highest and the lowest Amount (in current US$) of Haiti?
Make the answer very short. 8.93e+07. What is the difference between the highest and the lowest Amount (in current US$) in Honduras?
Your answer should be compact. 3.10e+08. What is the difference between the highest and the lowest Amount (in current US$) of Macedonia?
Offer a terse response. 9.96e+07. What is the difference between the highest and the lowest Amount (in current US$) of Vietnam?
Keep it short and to the point. 3.89e+08. 